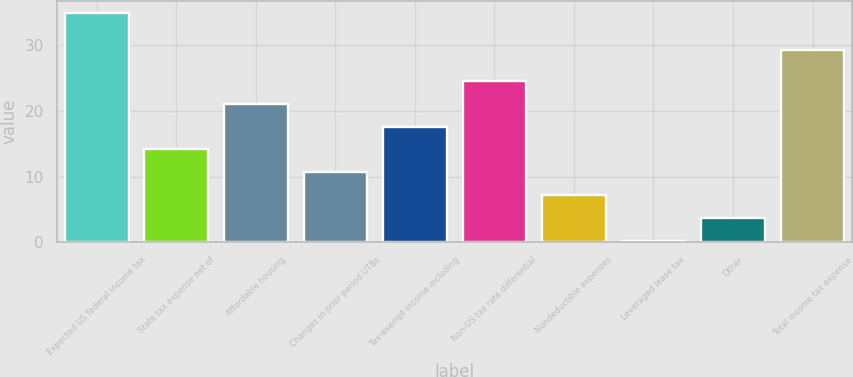Convert chart. <chart><loc_0><loc_0><loc_500><loc_500><bar_chart><fcel>Expected US federal income tax<fcel>State tax expense net of<fcel>Affordable housing<fcel>Changes in prior period UTBs<fcel>Tax-exempt income including<fcel>Non-US tax rate differential<fcel>Nondeductible expenses<fcel>Leveraged lease tax<fcel>Other<fcel>Total income tax expense<nl><fcel>35<fcel>14.12<fcel>21.08<fcel>10.64<fcel>17.6<fcel>24.56<fcel>7.16<fcel>0.2<fcel>3.68<fcel>29.3<nl></chart> 